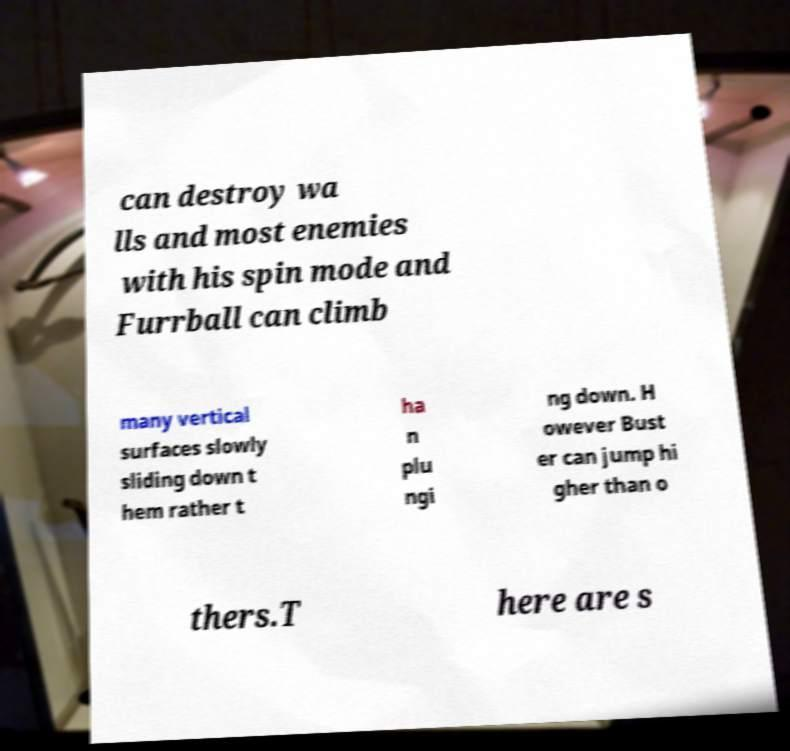Please read and relay the text visible in this image. What does it say? can destroy wa lls and most enemies with his spin mode and Furrball can climb many vertical surfaces slowly sliding down t hem rather t ha n plu ngi ng down. H owever Bust er can jump hi gher than o thers.T here are s 